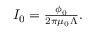<formula> <loc_0><loc_0><loc_500><loc_500>\begin{array} { r } { I _ { 0 } = \frac { \phi _ { 0 } } { 2 \pi \mu _ { 0 } \Lambda } . } \end{array}</formula> 